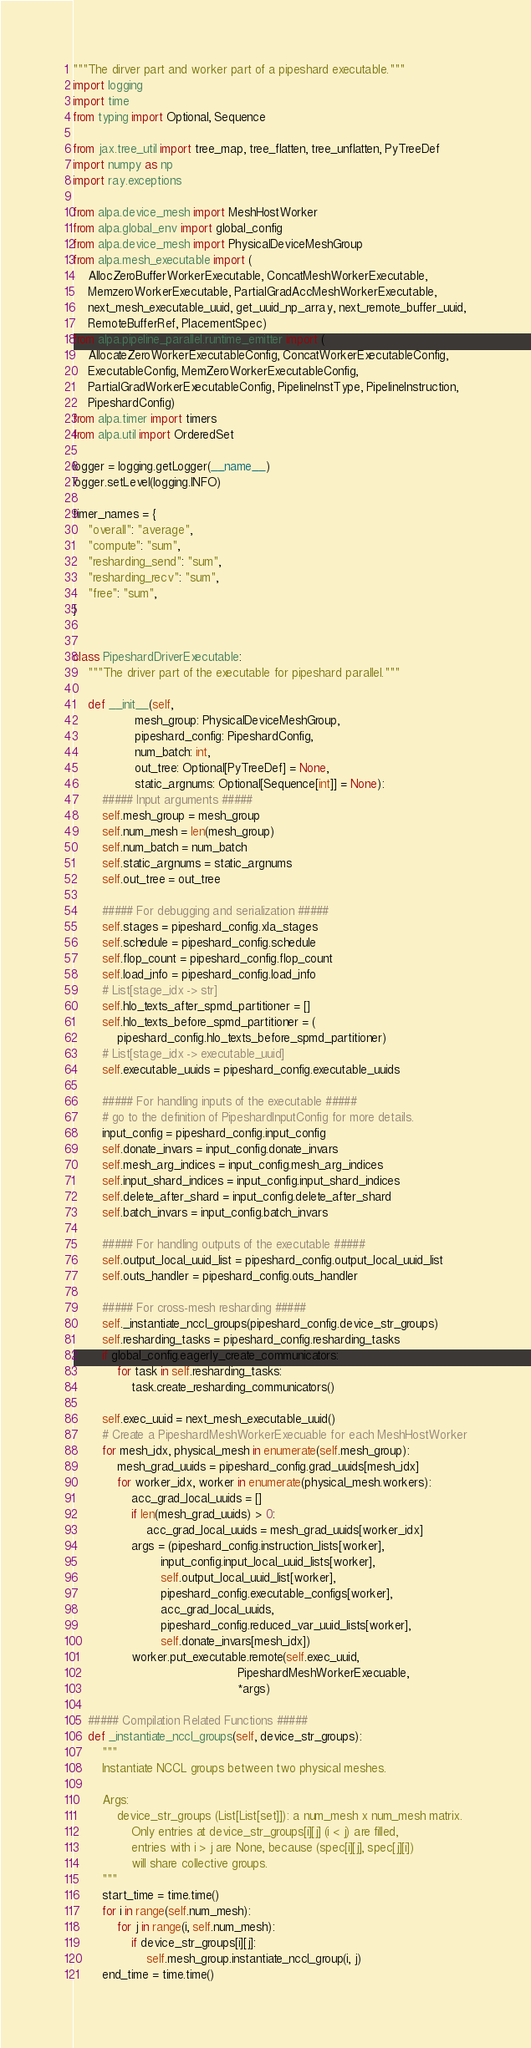Convert code to text. <code><loc_0><loc_0><loc_500><loc_500><_Python_>"""The dirver part and worker part of a pipeshard executable."""
import logging
import time
from typing import Optional, Sequence

from jax.tree_util import tree_map, tree_flatten, tree_unflatten, PyTreeDef
import numpy as np
import ray.exceptions

from alpa.device_mesh import MeshHostWorker
from alpa.global_env import global_config
from alpa.device_mesh import PhysicalDeviceMeshGroup
from alpa.mesh_executable import (
    AllocZeroBufferWorkerExecutable, ConcatMeshWorkerExecutable,
    MemzeroWorkerExecutable, PartialGradAccMeshWorkerExecutable,
    next_mesh_executable_uuid, get_uuid_np_array, next_remote_buffer_uuid,
    RemoteBufferRef, PlacementSpec)
from alpa.pipeline_parallel.runtime_emitter import (
    AllocateZeroWorkerExecutableConfig, ConcatWorkerExecutableConfig,
    ExecutableConfig, MemZeroWorkerExecutableConfig,
    PartialGradWorkerExecutableConfig, PipelineInstType, PipelineInstruction,
    PipeshardConfig)
from alpa.timer import timers
from alpa.util import OrderedSet

logger = logging.getLogger(__name__)
logger.setLevel(logging.INFO)

timer_names = {
    "overall": "average",
    "compute": "sum",
    "resharding_send": "sum",
    "resharding_recv": "sum",
    "free": "sum",
}


class PipeshardDriverExecutable:
    """The driver part of the executable for pipeshard parallel."""

    def __init__(self,
                 mesh_group: PhysicalDeviceMeshGroup,
                 pipeshard_config: PipeshardConfig,
                 num_batch: int,
                 out_tree: Optional[PyTreeDef] = None,
                 static_argnums: Optional[Sequence[int]] = None):
        ##### Input arguments #####
        self.mesh_group = mesh_group
        self.num_mesh = len(mesh_group)
        self.num_batch = num_batch
        self.static_argnums = static_argnums
        self.out_tree = out_tree

        ##### For debugging and serialization #####
        self.stages = pipeshard_config.xla_stages
        self.schedule = pipeshard_config.schedule
        self.flop_count = pipeshard_config.flop_count
        self.load_info = pipeshard_config.load_info
        # List[stage_idx -> str]
        self.hlo_texts_after_spmd_partitioner = []
        self.hlo_texts_before_spmd_partitioner = (
            pipeshard_config.hlo_texts_before_spmd_partitioner)
        # List[stage_idx -> executable_uuid]
        self.executable_uuids = pipeshard_config.executable_uuids

        ##### For handling inputs of the executable #####
        # go to the definition of PipeshardInputConfig for more details.
        input_config = pipeshard_config.input_config
        self.donate_invars = input_config.donate_invars
        self.mesh_arg_indices = input_config.mesh_arg_indices
        self.input_shard_indices = input_config.input_shard_indices
        self.delete_after_shard = input_config.delete_after_shard
        self.batch_invars = input_config.batch_invars

        ##### For handling outputs of the executable #####
        self.output_local_uuid_list = pipeshard_config.output_local_uuid_list
        self.outs_handler = pipeshard_config.outs_handler

        ##### For cross-mesh resharding #####
        self._instantiate_nccl_groups(pipeshard_config.device_str_groups)
        self.resharding_tasks = pipeshard_config.resharding_tasks
        if global_config.eagerly_create_communicators:
            for task in self.resharding_tasks:
                task.create_resharding_communicators()

        self.exec_uuid = next_mesh_executable_uuid()
        # Create a PipeshardMeshWorkerExecuable for each MeshHostWorker
        for mesh_idx, physical_mesh in enumerate(self.mesh_group):
            mesh_grad_uuids = pipeshard_config.grad_uuids[mesh_idx]
            for worker_idx, worker in enumerate(physical_mesh.workers):
                acc_grad_local_uuids = []
                if len(mesh_grad_uuids) > 0:
                    acc_grad_local_uuids = mesh_grad_uuids[worker_idx]
                args = (pipeshard_config.instruction_lists[worker],
                        input_config.input_local_uuid_lists[worker],
                        self.output_local_uuid_list[worker],
                        pipeshard_config.executable_configs[worker],
                        acc_grad_local_uuids,
                        pipeshard_config.reduced_var_uuid_lists[worker],
                        self.donate_invars[mesh_idx])
                worker.put_executable.remote(self.exec_uuid,
                                             PipeshardMeshWorkerExecuable,
                                             *args)

    ##### Compilation Related Functions #####
    def _instantiate_nccl_groups(self, device_str_groups):
        """
        Instantiate NCCL groups between two physical meshes.

        Args:
            device_str_groups (List[List[set]]): a num_mesh x num_mesh matrix.
                Only entries at device_str_groups[i][j] (i < j) are filled,
                entries with i > j are None, because (spec[i][j], spec[j][i])
                will share collective groups.
        """
        start_time = time.time()
        for i in range(self.num_mesh):
            for j in range(i, self.num_mesh):
                if device_str_groups[i][j]:
                    self.mesh_group.instantiate_nccl_group(i, j)
        end_time = time.time()</code> 